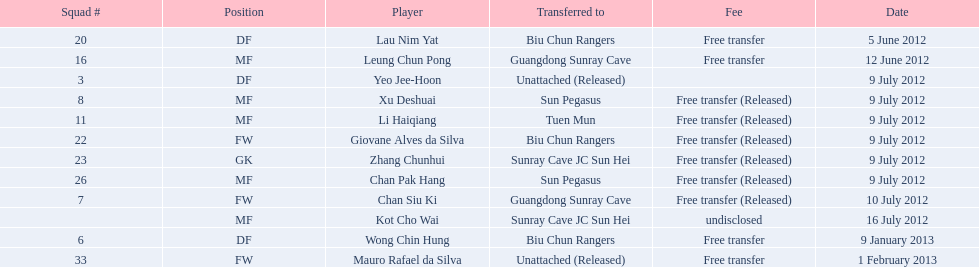Which team did lau nim yat play for after he was transferred? Biu Chun Rangers. Could you parse the entire table? {'header': ['Squad #', 'Position', 'Player', 'Transferred to', 'Fee', 'Date'], 'rows': [['20', 'DF', 'Lau Nim Yat', 'Biu Chun Rangers', 'Free transfer', '5 June 2012'], ['16', 'MF', 'Leung Chun Pong', 'Guangdong Sunray Cave', 'Free transfer', '12 June 2012'], ['3', 'DF', 'Yeo Jee-Hoon', 'Unattached (Released)', '', '9 July 2012'], ['8', 'MF', 'Xu Deshuai', 'Sun Pegasus', 'Free transfer (Released)', '9 July 2012'], ['11', 'MF', 'Li Haiqiang', 'Tuen Mun', 'Free transfer (Released)', '9 July 2012'], ['22', 'FW', 'Giovane Alves da Silva', 'Biu Chun Rangers', 'Free transfer (Released)', '9 July 2012'], ['23', 'GK', 'Zhang Chunhui', 'Sunray Cave JC Sun Hei', 'Free transfer (Released)', '9 July 2012'], ['26', 'MF', 'Chan Pak Hang', 'Sun Pegasus', 'Free transfer (Released)', '9 July 2012'], ['7', 'FW', 'Chan Siu Ki', 'Guangdong Sunray Cave', 'Free transfer (Released)', '10 July 2012'], ['', 'MF', 'Kot Cho Wai', 'Sunray Cave JC Sun Hei', 'undisclosed', '16 July 2012'], ['6', 'DF', 'Wong Chin Hung', 'Biu Chun Rangers', 'Free transfer', '9 January 2013'], ['33', 'FW', 'Mauro Rafael da Silva', 'Unattached (Released)', 'Free transfer', '1 February 2013']]} 